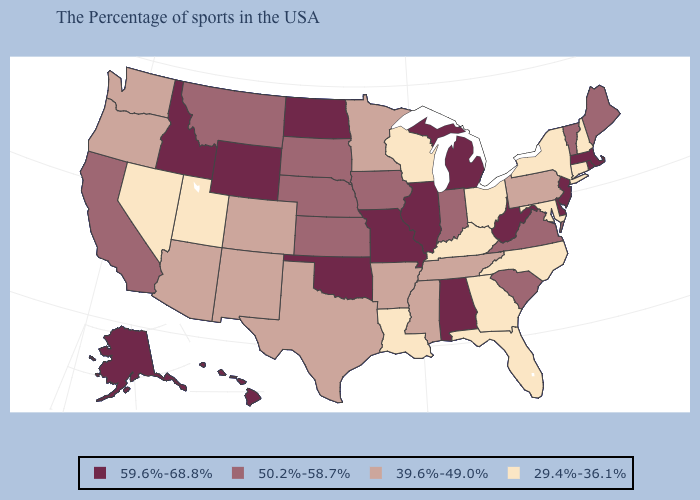Which states have the highest value in the USA?
Concise answer only. Massachusetts, Rhode Island, New Jersey, Delaware, West Virginia, Michigan, Alabama, Illinois, Missouri, Oklahoma, North Dakota, Wyoming, Idaho, Alaska, Hawaii. What is the value of Utah?
Write a very short answer. 29.4%-36.1%. Does Utah have the lowest value in the West?
Give a very brief answer. Yes. Among the states that border Minnesota , does Iowa have the highest value?
Concise answer only. No. What is the lowest value in states that border Wisconsin?
Quick response, please. 39.6%-49.0%. Name the states that have a value in the range 59.6%-68.8%?
Concise answer only. Massachusetts, Rhode Island, New Jersey, Delaware, West Virginia, Michigan, Alabama, Illinois, Missouri, Oklahoma, North Dakota, Wyoming, Idaho, Alaska, Hawaii. Does Washington have the highest value in the West?
Be succinct. No. Which states hav the highest value in the MidWest?
Concise answer only. Michigan, Illinois, Missouri, North Dakota. What is the value of Mississippi?
Give a very brief answer. 39.6%-49.0%. What is the value of Kansas?
Concise answer only. 50.2%-58.7%. Among the states that border Colorado , which have the highest value?
Be succinct. Oklahoma, Wyoming. Among the states that border Ohio , which have the highest value?
Keep it brief. West Virginia, Michigan. Among the states that border Colorado , does Nebraska have the highest value?
Short answer required. No. Does California have the lowest value in the USA?
Keep it brief. No. Does North Dakota have the highest value in the MidWest?
Concise answer only. Yes. 